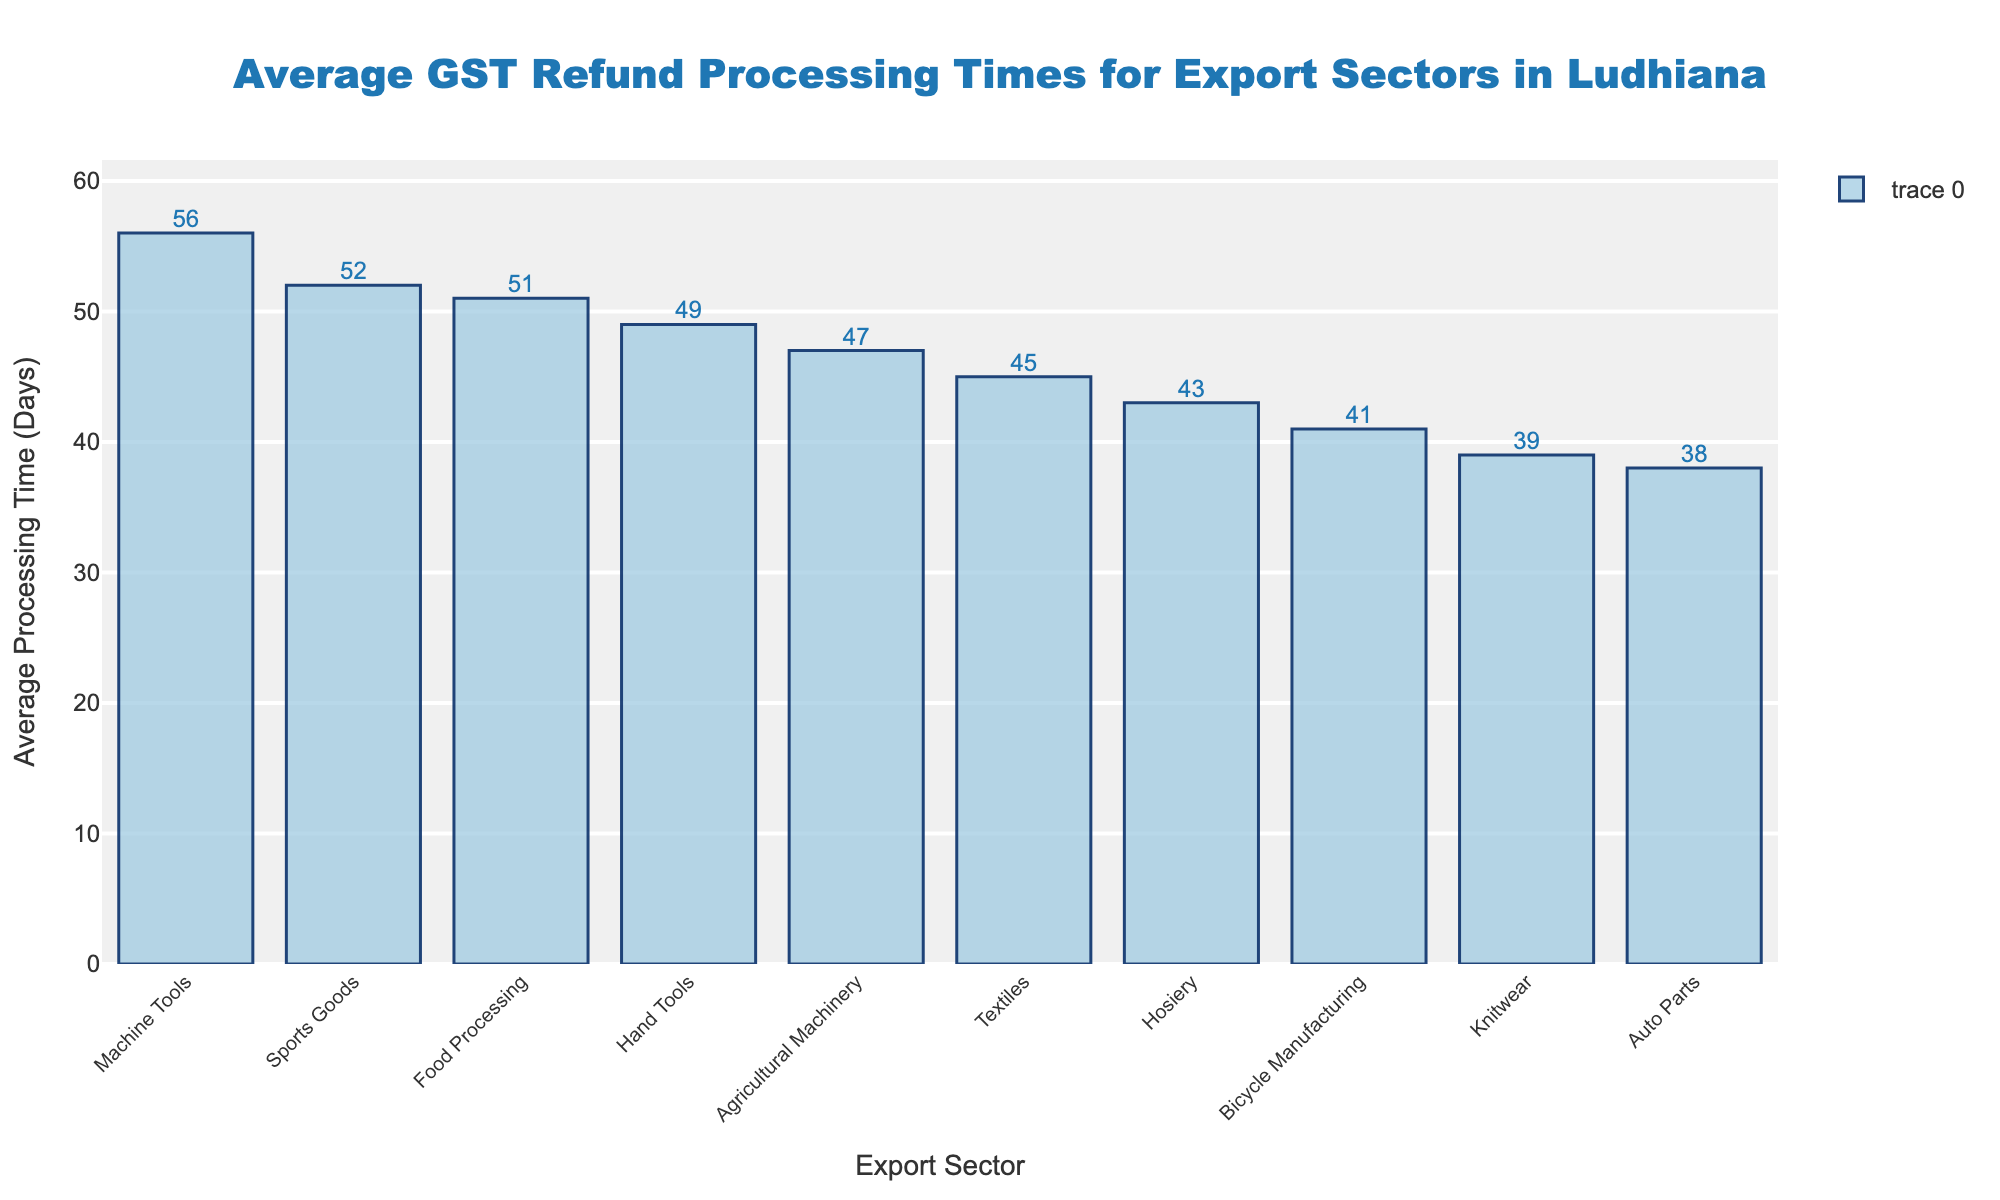How does the processing time for Sports Goods compare to Machine Tools? By examining the heights of the bars in the chart, we can see that the bar for Sports Goods is slightly shorter than the bar for Machine Tools, indicating a smaller processing time. Specifically, Sports Goods has an average processing time of 52 days, whereas Machine Tools has 56 days.
Answer: Sports Goods: 52 days, Machine Tools: 56 days What is the difference in processing time between the Textile sector and the Auto Parts sector? The bar for the Textile sector is longer than that for the Auto Parts sector. The Textile sector has an average processing time of 45 days, while the Auto Parts sector has 38 days. Hence, the difference is 45 - 38 = 7 days.
Answer: 7 days Which sector has the longest average processing time, and how long is it? By looking at the heights of the bars, the Machine Tools sector has the longest average processing time. The label on the top center of the bar shows it to be 56 days.
Answer: Machine Tools: 56 days What is the total average processing time if we sum the averages for Knitwear, Food Processing, and Hosiery sectors? First, locate the respective bars and note their processing times: Knitwear (39 days), Food Processing (51 days), and Hosiery (43 days). Summing these, we get 39 + 51 + 43 = 133 days.
Answer: 133 days Which sector has a shorter processing time: Bicycle Manufacturing or Agricultural Machinery? By comparing the heights of their bars, Bicycle Manufacturing has an average processing time of 41 days, whereas Agricultural Machinery has 47 days. The shorter processing time is for the Bicycle Manufacturing sector.
Answer: Bicycle Manufacturing: 41 days What is the average processing time for the sectors with processing times above 50 days? Identify the sectors with processing times longer than 50 days: Sports Goods (52 days), Machine Tools (56 days), and Food Processing (51 days). The average is calculated as (52 + 56 + 51) / 3 = 53 days.
Answer: 53 days Is the average processing time for Hand Tools greater than or less than Knitwear? By examining the bars, Hand Tools has an average processing time of 49 days, whereas Knitwear has 39 days. Hand Tools has a greater processing time.
Answer: Greater How do the processing times for the top three sectors in terms of average days compare? The three sectors with the longest average processing times are Machine Tools (56 days), Sports Goods (52 days), and Food Processing (51 days). Comparing them shows Machine Tools has the highest, followed by Sports Goods, and then Food Processing.
Answer: 56 > 52 > 51 